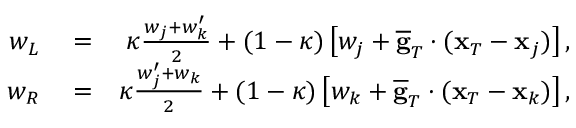<formula> <loc_0><loc_0><loc_500><loc_500>\begin{array} { r l r } { w _ { L } } & = } & { \kappa \frac { w _ { j } + w _ { k } ^ { \prime } } { 2 } + ( 1 - \kappa ) \left [ w _ { j } + \overline { g } _ { T } \cdot ( { x } _ { T } - { x } _ { j } ) \right ] , } \\ { w _ { R } } & = } & { \kappa \frac { w _ { j } ^ { \prime } + w _ { k } } { 2 } + ( 1 - \kappa ) \left [ w _ { k } + \overline { g } _ { T } \cdot ( { x } _ { T } - { x } _ { k } ) \right ] , } \end{array}</formula> 